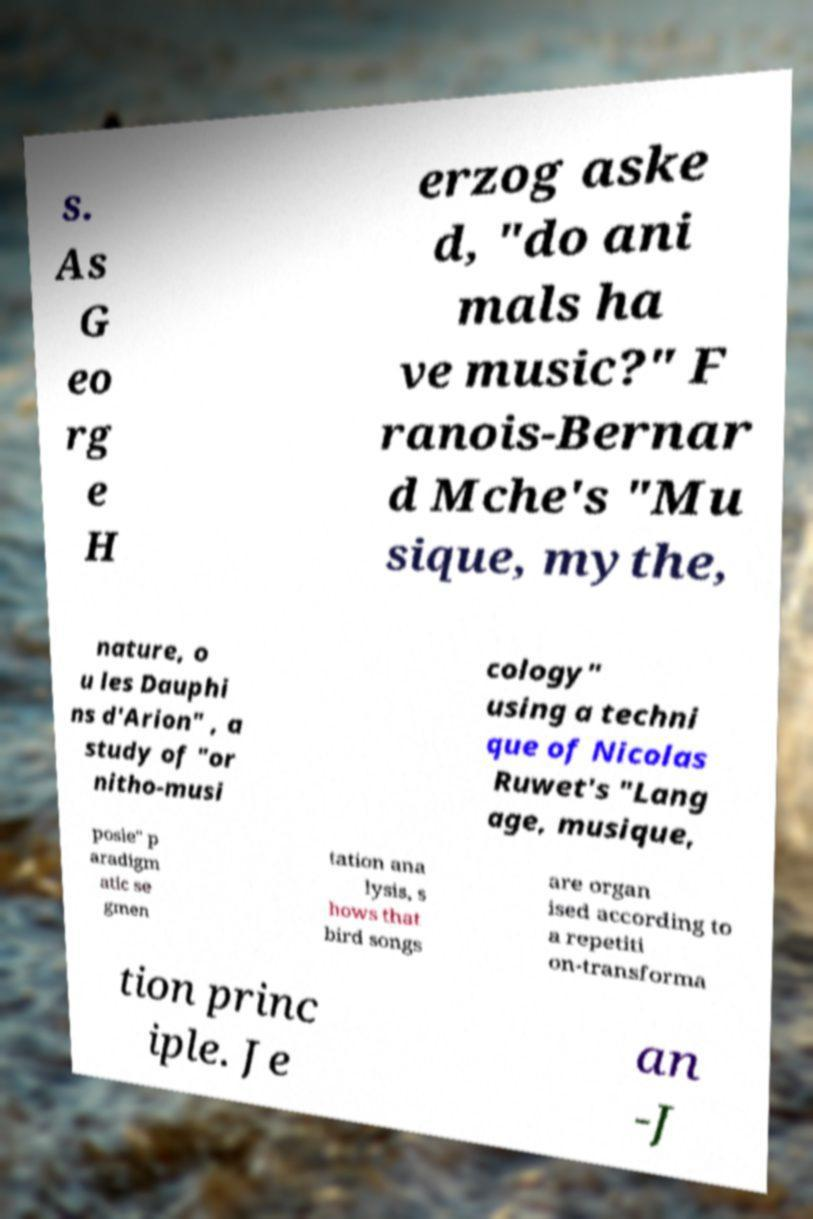Can you accurately transcribe the text from the provided image for me? s. As G eo rg e H erzog aske d, "do ani mals ha ve music?" F ranois-Bernar d Mche's "Mu sique, mythe, nature, o u les Dauphi ns d'Arion" , a study of "or nitho-musi cology" using a techni que of Nicolas Ruwet's "Lang age, musique, posie" p aradigm atic se gmen tation ana lysis, s hows that bird songs are organ ised according to a repetiti on-transforma tion princ iple. Je an -J 